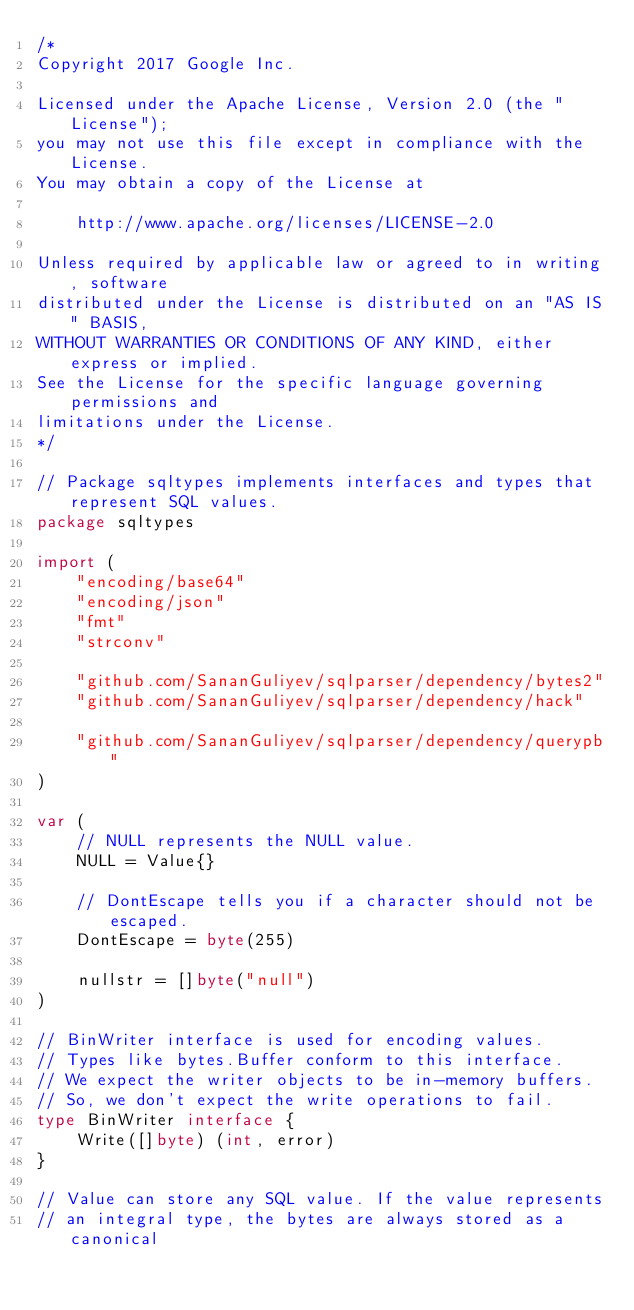<code> <loc_0><loc_0><loc_500><loc_500><_Go_>/*
Copyright 2017 Google Inc.

Licensed under the Apache License, Version 2.0 (the "License");
you may not use this file except in compliance with the License.
You may obtain a copy of the License at

    http://www.apache.org/licenses/LICENSE-2.0

Unless required by applicable law or agreed to in writing, software
distributed under the License is distributed on an "AS IS" BASIS,
WITHOUT WARRANTIES OR CONDITIONS OF ANY KIND, either express or implied.
See the License for the specific language governing permissions and
limitations under the License.
*/

// Package sqltypes implements interfaces and types that represent SQL values.
package sqltypes

import (
	"encoding/base64"
	"encoding/json"
	"fmt"
	"strconv"

	"github.com/SananGuliyev/sqlparser/dependency/bytes2"
	"github.com/SananGuliyev/sqlparser/dependency/hack"

	"github.com/SananGuliyev/sqlparser/dependency/querypb"
)

var (
	// NULL represents the NULL value.
	NULL = Value{}

	// DontEscape tells you if a character should not be escaped.
	DontEscape = byte(255)

	nullstr = []byte("null")
)

// BinWriter interface is used for encoding values.
// Types like bytes.Buffer conform to this interface.
// We expect the writer objects to be in-memory buffers.
// So, we don't expect the write operations to fail.
type BinWriter interface {
	Write([]byte) (int, error)
}

// Value can store any SQL value. If the value represents
// an integral type, the bytes are always stored as a canonical</code> 